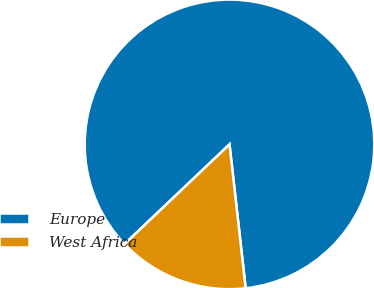Convert chart to OTSL. <chart><loc_0><loc_0><loc_500><loc_500><pie_chart><fcel>Europe<fcel>West Africa<nl><fcel>85.31%<fcel>14.69%<nl></chart> 